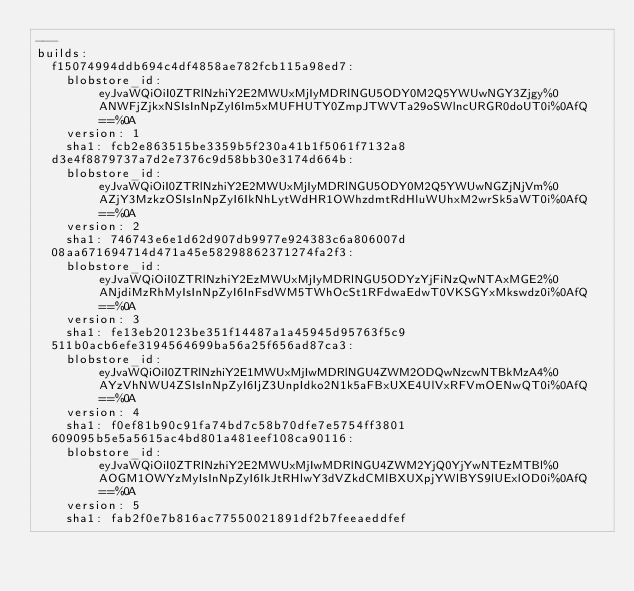Convert code to text. <code><loc_0><loc_0><loc_500><loc_500><_YAML_>--- 
builds: 
  f15074994ddb694c4df4858ae782fcb115a98ed7: 
    blobstore_id: eyJvaWQiOiI0ZTRlNzhiY2E2MWUxMjIyMDRlNGU5ODY0M2Q5YWUwNGY3Zjgy%0ANWFjZjkxNSIsInNpZyI6Im5xMUFHUTY0ZmpJTWVTa29oSWlncURGR0doUT0i%0AfQ==%0A
    version: 1
    sha1: fcb2e863515be3359b5f230a41b1f5061f7132a8
  d3e4f8879737a7d2e7376c9d58bb30e3174d664b: 
    blobstore_id: eyJvaWQiOiI0ZTRlNzhiY2E2MWUxMjIyMDRlNGU5ODY0M2Q5YWUwNGZjNjVm%0AZjY3MzkzOSIsInNpZyI6IkNhLytWdHR1OWhzdmtRdHluWUhxM2wrSk5aWT0i%0AfQ==%0A
    version: 2
    sha1: 746743e6e1d62d907db9977e924383c6a806007d
  08aa671694714d471a45e58298862371274fa2f3: 
    blobstore_id: eyJvaWQiOiI0ZTRlNzhiY2EzMWUxMjIyMDRlNGU5ODYzYjFiNzQwNTAxMGE2%0ANjdiMzRhMyIsInNpZyI6InFsdWM5TWhOcSt1RFdwaEdwT0VKSGYxMkswdz0i%0AfQ==%0A
    version: 3
    sha1: fe13eb20123be351f14487a1a45945d95763f5c9
  511b0acb6efe3194564699ba56a25f656ad87ca3: 
    blobstore_id: eyJvaWQiOiI0ZTRlNzhiY2E1MWUxMjIwMDRlNGU4ZWM2ODQwNzcwNTBkMzA4%0AYzVhNWU4ZSIsInNpZyI6IjZ3UnpIdko2N1k5aFBxUXE4UlVxRFVmOENwQT0i%0AfQ==%0A
    version: 4
    sha1: f0ef81b90c91fa74bd7c58b70dfe7e5754ff3801
  609095b5e5a5615ac4bd801a481eef108ca90116: 
    blobstore_id: eyJvaWQiOiI0ZTRlNzhiY2E2MWUxMjIwMDRlNGU4ZWM2YjQ0YjYwNTEzMTBl%0AOGM1OWYzMyIsInNpZyI6IkJtRHlwY3dVZkdCMlBXUXpjYWlBYS9lUExlOD0i%0AfQ==%0A
    version: 5
    sha1: fab2f0e7b816ac77550021891df2b7feeaeddfef
</code> 